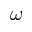<formula> <loc_0><loc_0><loc_500><loc_500>{ \boldsymbol \omega }</formula> 